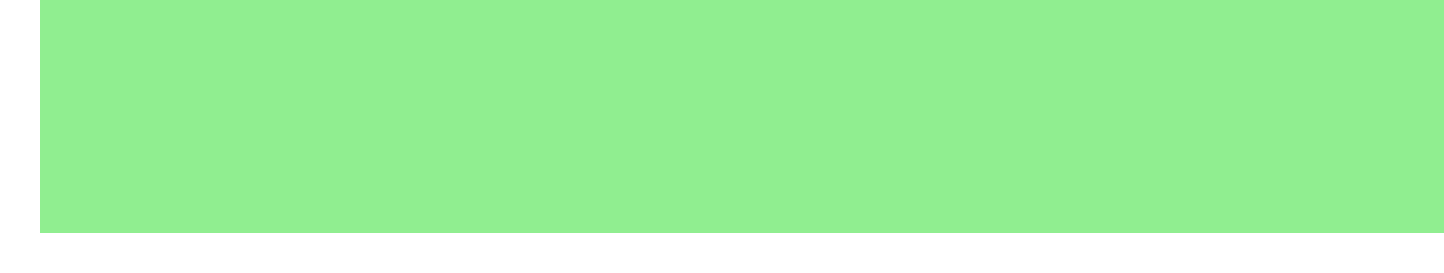What is the name of the software? The name of the software is listed in the Software Details section of the document.
Answer: EcoImpact Pro What is the duration of the license? The duration of the license is provided under License Information.
Answer: 3 years How many licenses are included in the purchase? The number of licenses is specified in the License Information section.
Answer: 25 What is the base price per license per year? The base price is detailed in the Subscription Details section of the document.
Answer: $8,500 What is the total maintenance fee over 3 years? The total maintenance fee can be calculated by multiplying the annual fee by 3 years.
Answer: $75,000 What are the basic course costs per user? The cost for the basic course is mentioned under the Training Package section.
Answer: $500 per user What is the cost for on-site training? The document specifies the cost for on-site training under the Training Package section.
Answer: $15,000 What is the late payment fee? The fee for late payment is detailed under the Payment Terms section of the document.
Answer: 2% per month What is the cost for data migration? The cost for data migration is explicitly stated under Additional Services in the document.
Answer: $10,000 flat fee 